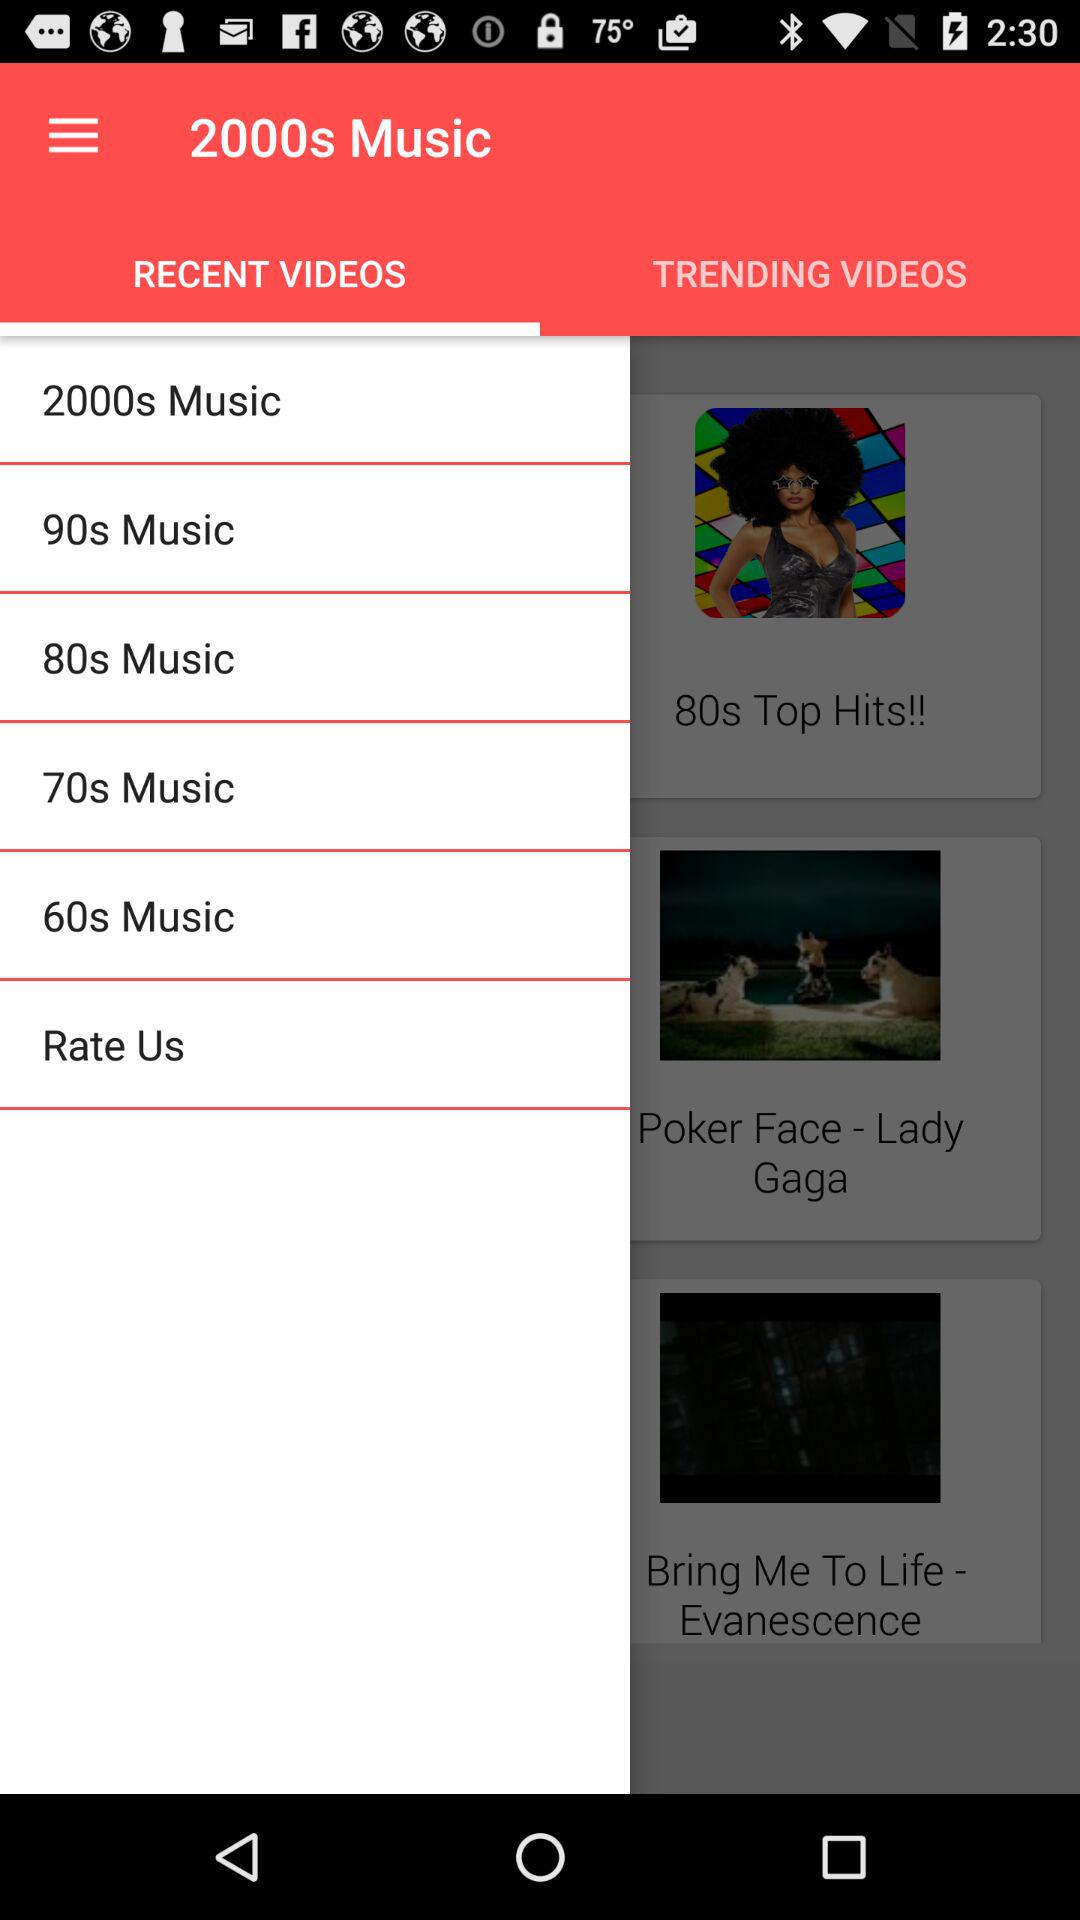Can you describe the design and layout of the app shown? The app showcased in the image features a vibrant red header with the text '2000s Music'. The main menu is simply structured, offering selections by decade like '2000s Music', '90s Music', '80s Music', and '70s Music'. Each playlist option is designed as a red horizontal bar with white text. The app also displays recently added and trending videos, highlighting popular hits such as 'Poker Face - Lady Gaga' and 'Bring Me To Life - Evanescence'. 